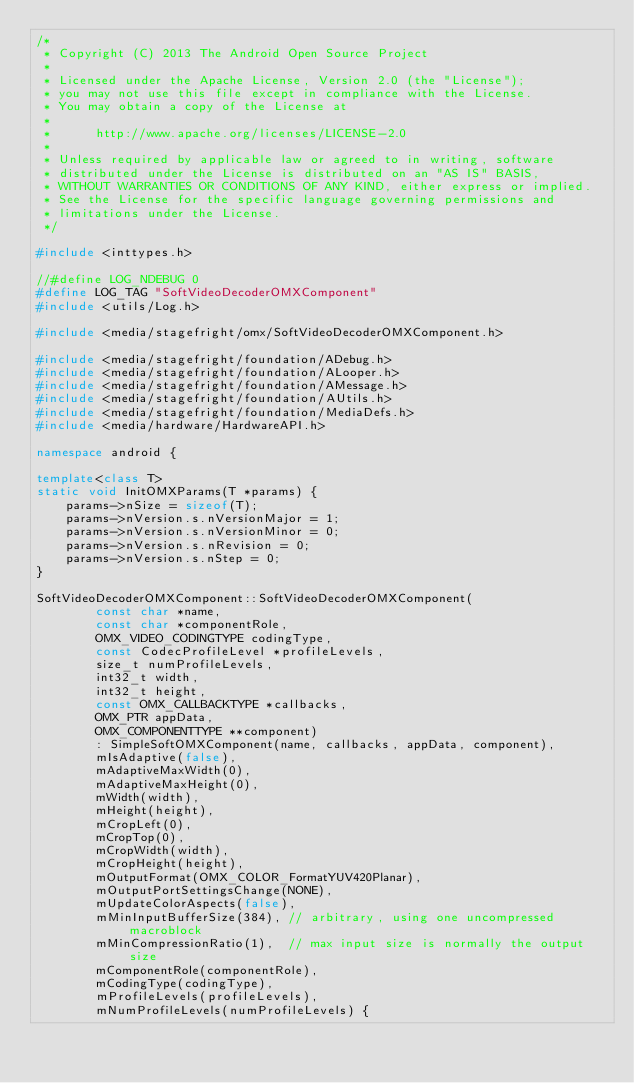Convert code to text. <code><loc_0><loc_0><loc_500><loc_500><_C++_>/*
 * Copyright (C) 2013 The Android Open Source Project
 *
 * Licensed under the Apache License, Version 2.0 (the "License");
 * you may not use this file except in compliance with the License.
 * You may obtain a copy of the License at
 *
 *      http://www.apache.org/licenses/LICENSE-2.0
 *
 * Unless required by applicable law or agreed to in writing, software
 * distributed under the License is distributed on an "AS IS" BASIS,
 * WITHOUT WARRANTIES OR CONDITIONS OF ANY KIND, either express or implied.
 * See the License for the specific language governing permissions and
 * limitations under the License.
 */

#include <inttypes.h>

//#define LOG_NDEBUG 0
#define LOG_TAG "SoftVideoDecoderOMXComponent"
#include <utils/Log.h>

#include <media/stagefright/omx/SoftVideoDecoderOMXComponent.h>

#include <media/stagefright/foundation/ADebug.h>
#include <media/stagefright/foundation/ALooper.h>
#include <media/stagefright/foundation/AMessage.h>
#include <media/stagefright/foundation/AUtils.h>
#include <media/stagefright/foundation/MediaDefs.h>
#include <media/hardware/HardwareAPI.h>

namespace android {

template<class T>
static void InitOMXParams(T *params) {
    params->nSize = sizeof(T);
    params->nVersion.s.nVersionMajor = 1;
    params->nVersion.s.nVersionMinor = 0;
    params->nVersion.s.nRevision = 0;
    params->nVersion.s.nStep = 0;
}

SoftVideoDecoderOMXComponent::SoftVideoDecoderOMXComponent(
        const char *name,
        const char *componentRole,
        OMX_VIDEO_CODINGTYPE codingType,
        const CodecProfileLevel *profileLevels,
        size_t numProfileLevels,
        int32_t width,
        int32_t height,
        const OMX_CALLBACKTYPE *callbacks,
        OMX_PTR appData,
        OMX_COMPONENTTYPE **component)
        : SimpleSoftOMXComponent(name, callbacks, appData, component),
        mIsAdaptive(false),
        mAdaptiveMaxWidth(0),
        mAdaptiveMaxHeight(0),
        mWidth(width),
        mHeight(height),
        mCropLeft(0),
        mCropTop(0),
        mCropWidth(width),
        mCropHeight(height),
        mOutputFormat(OMX_COLOR_FormatYUV420Planar),
        mOutputPortSettingsChange(NONE),
        mUpdateColorAspects(false),
        mMinInputBufferSize(384), // arbitrary, using one uncompressed macroblock
        mMinCompressionRatio(1),  // max input size is normally the output size
        mComponentRole(componentRole),
        mCodingType(codingType),
        mProfileLevels(profileLevels),
        mNumProfileLevels(numProfileLevels) {
</code> 